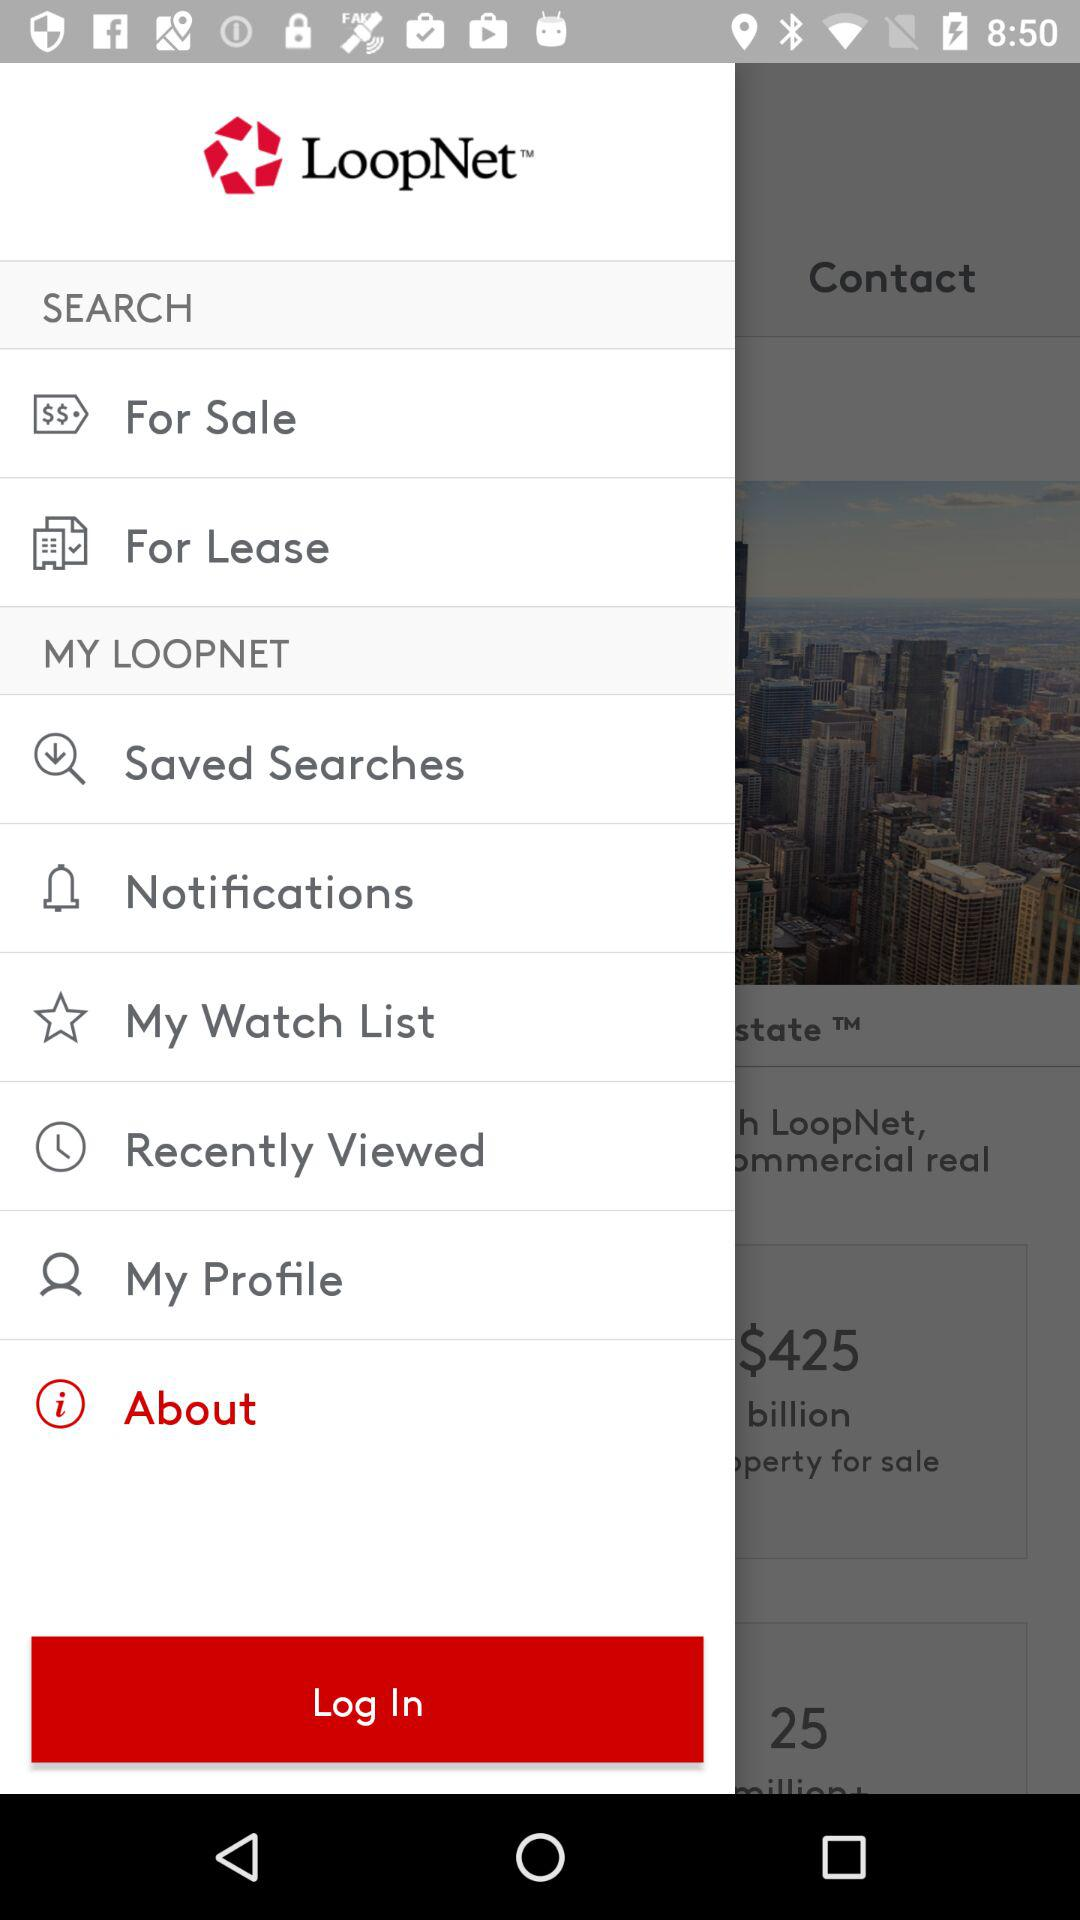What is the name of the application? The name of the application is "LoopNet". 